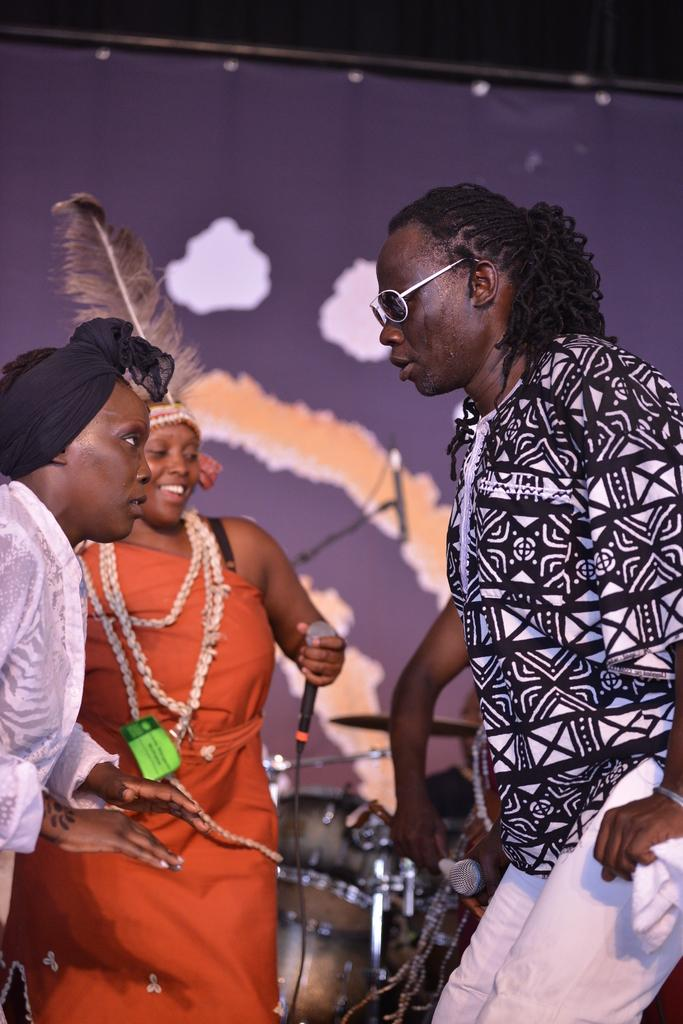How many people are present in the image? There are three people in the image: one man and two women. What is one of the women holding in her hand? One of the women is holding a mic in her hand. What else can be seen in the image besides the people? There are musical instruments visible in the image. How does the image change when the man starts asking questions? The image does not change when the man starts asking questions, as it is a still image and cannot depict any actions or changes. 